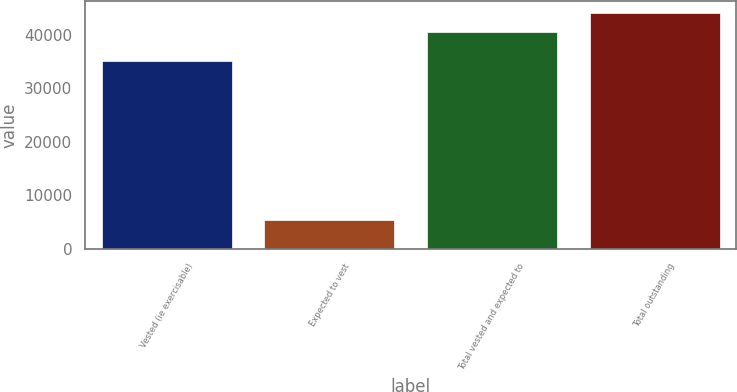Convert chart to OTSL. <chart><loc_0><loc_0><loc_500><loc_500><bar_chart><fcel>Vested (ie exercisable)<fcel>Expected to vest<fcel>Total vested and expected to<fcel>Total outstanding<nl><fcel>35059<fcel>5490<fcel>40549<fcel>44102.1<nl></chart> 